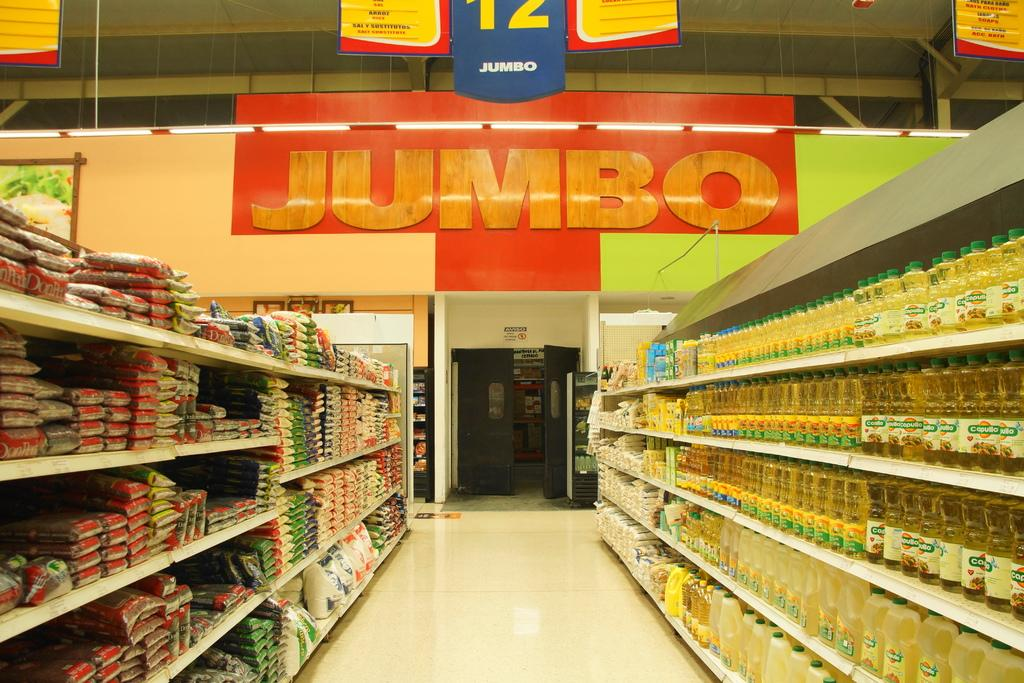<image>
Describe the image concisely. A food aisle in an empty Jumbo grocery store. 